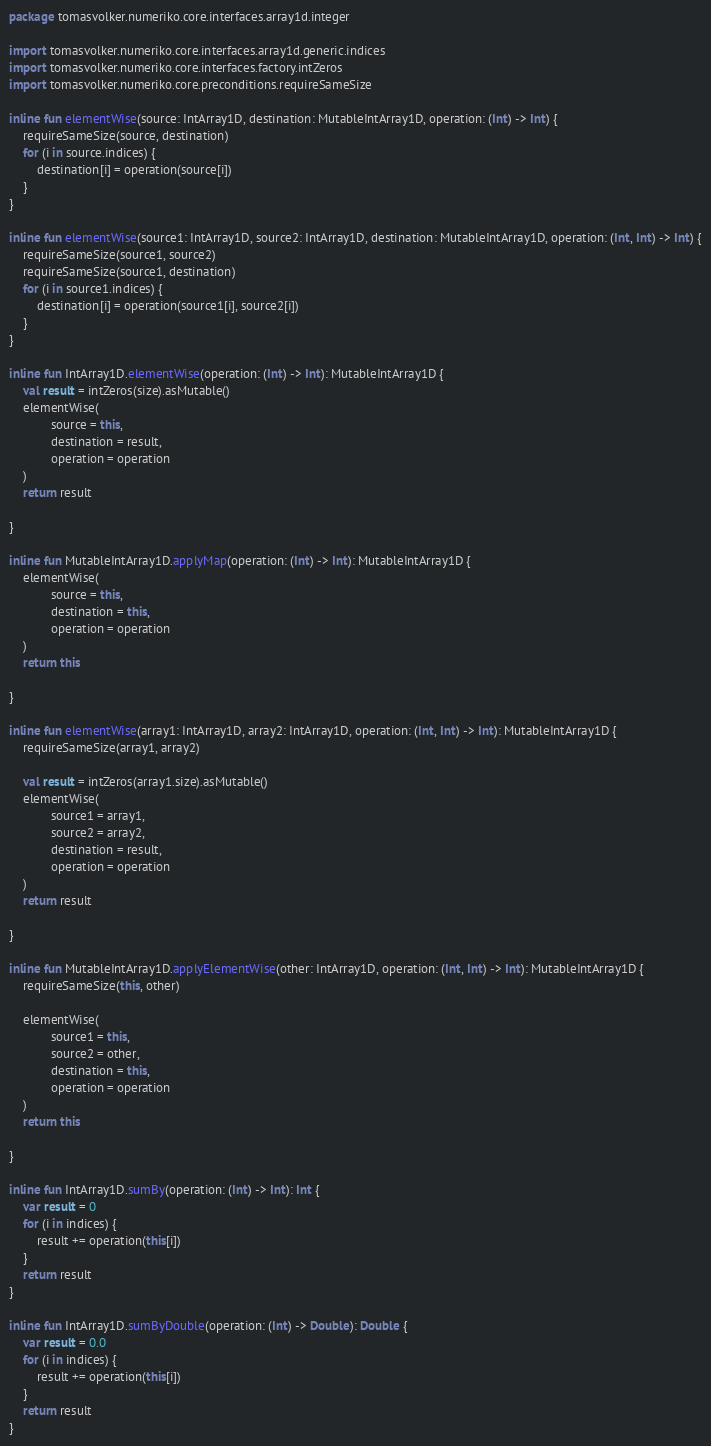<code> <loc_0><loc_0><loc_500><loc_500><_Kotlin_>package tomasvolker.numeriko.core.interfaces.array1d.integer

import tomasvolker.numeriko.core.interfaces.array1d.generic.indices
import tomasvolker.numeriko.core.interfaces.factory.intZeros
import tomasvolker.numeriko.core.preconditions.requireSameSize

inline fun elementWise(source: IntArray1D, destination: MutableIntArray1D, operation: (Int) -> Int) {
    requireSameSize(source, destination)
    for (i in source.indices) {
        destination[i] = operation(source[i])
    }
}

inline fun elementWise(source1: IntArray1D, source2: IntArray1D, destination: MutableIntArray1D, operation: (Int, Int) -> Int) {
    requireSameSize(source1, source2)
    requireSameSize(source1, destination)
    for (i in source1.indices) {
        destination[i] = operation(source1[i], source2[i])
    }
}

inline fun IntArray1D.elementWise(operation: (Int) -> Int): MutableIntArray1D {
    val result = intZeros(size).asMutable()
    elementWise(
            source = this,
            destination = result,
            operation = operation
    )
    return result

}

inline fun MutableIntArray1D.applyMap(operation: (Int) -> Int): MutableIntArray1D {
    elementWise(
            source = this,
            destination = this,
            operation = operation
    )
    return this

}

inline fun elementWise(array1: IntArray1D, array2: IntArray1D, operation: (Int, Int) -> Int): MutableIntArray1D {
    requireSameSize(array1, array2)

    val result = intZeros(array1.size).asMutable()
    elementWise(
            source1 = array1,
            source2 = array2,
            destination = result,
            operation = operation
    )
    return result

}

inline fun MutableIntArray1D.applyElementWise(other: IntArray1D, operation: (Int, Int) -> Int): MutableIntArray1D {
    requireSameSize(this, other)

    elementWise(
            source1 = this,
            source2 = other,
            destination = this,
            operation = operation
    )
    return this

}

inline fun IntArray1D.sumBy(operation: (Int) -> Int): Int {
    var result = 0
    for (i in indices) {
        result += operation(this[i])
    }
    return result
}

inline fun IntArray1D.sumByDouble(operation: (Int) -> Double): Double {
    var result = 0.0
    for (i in indices) {
        result += operation(this[i])
    }
    return result
}
</code> 